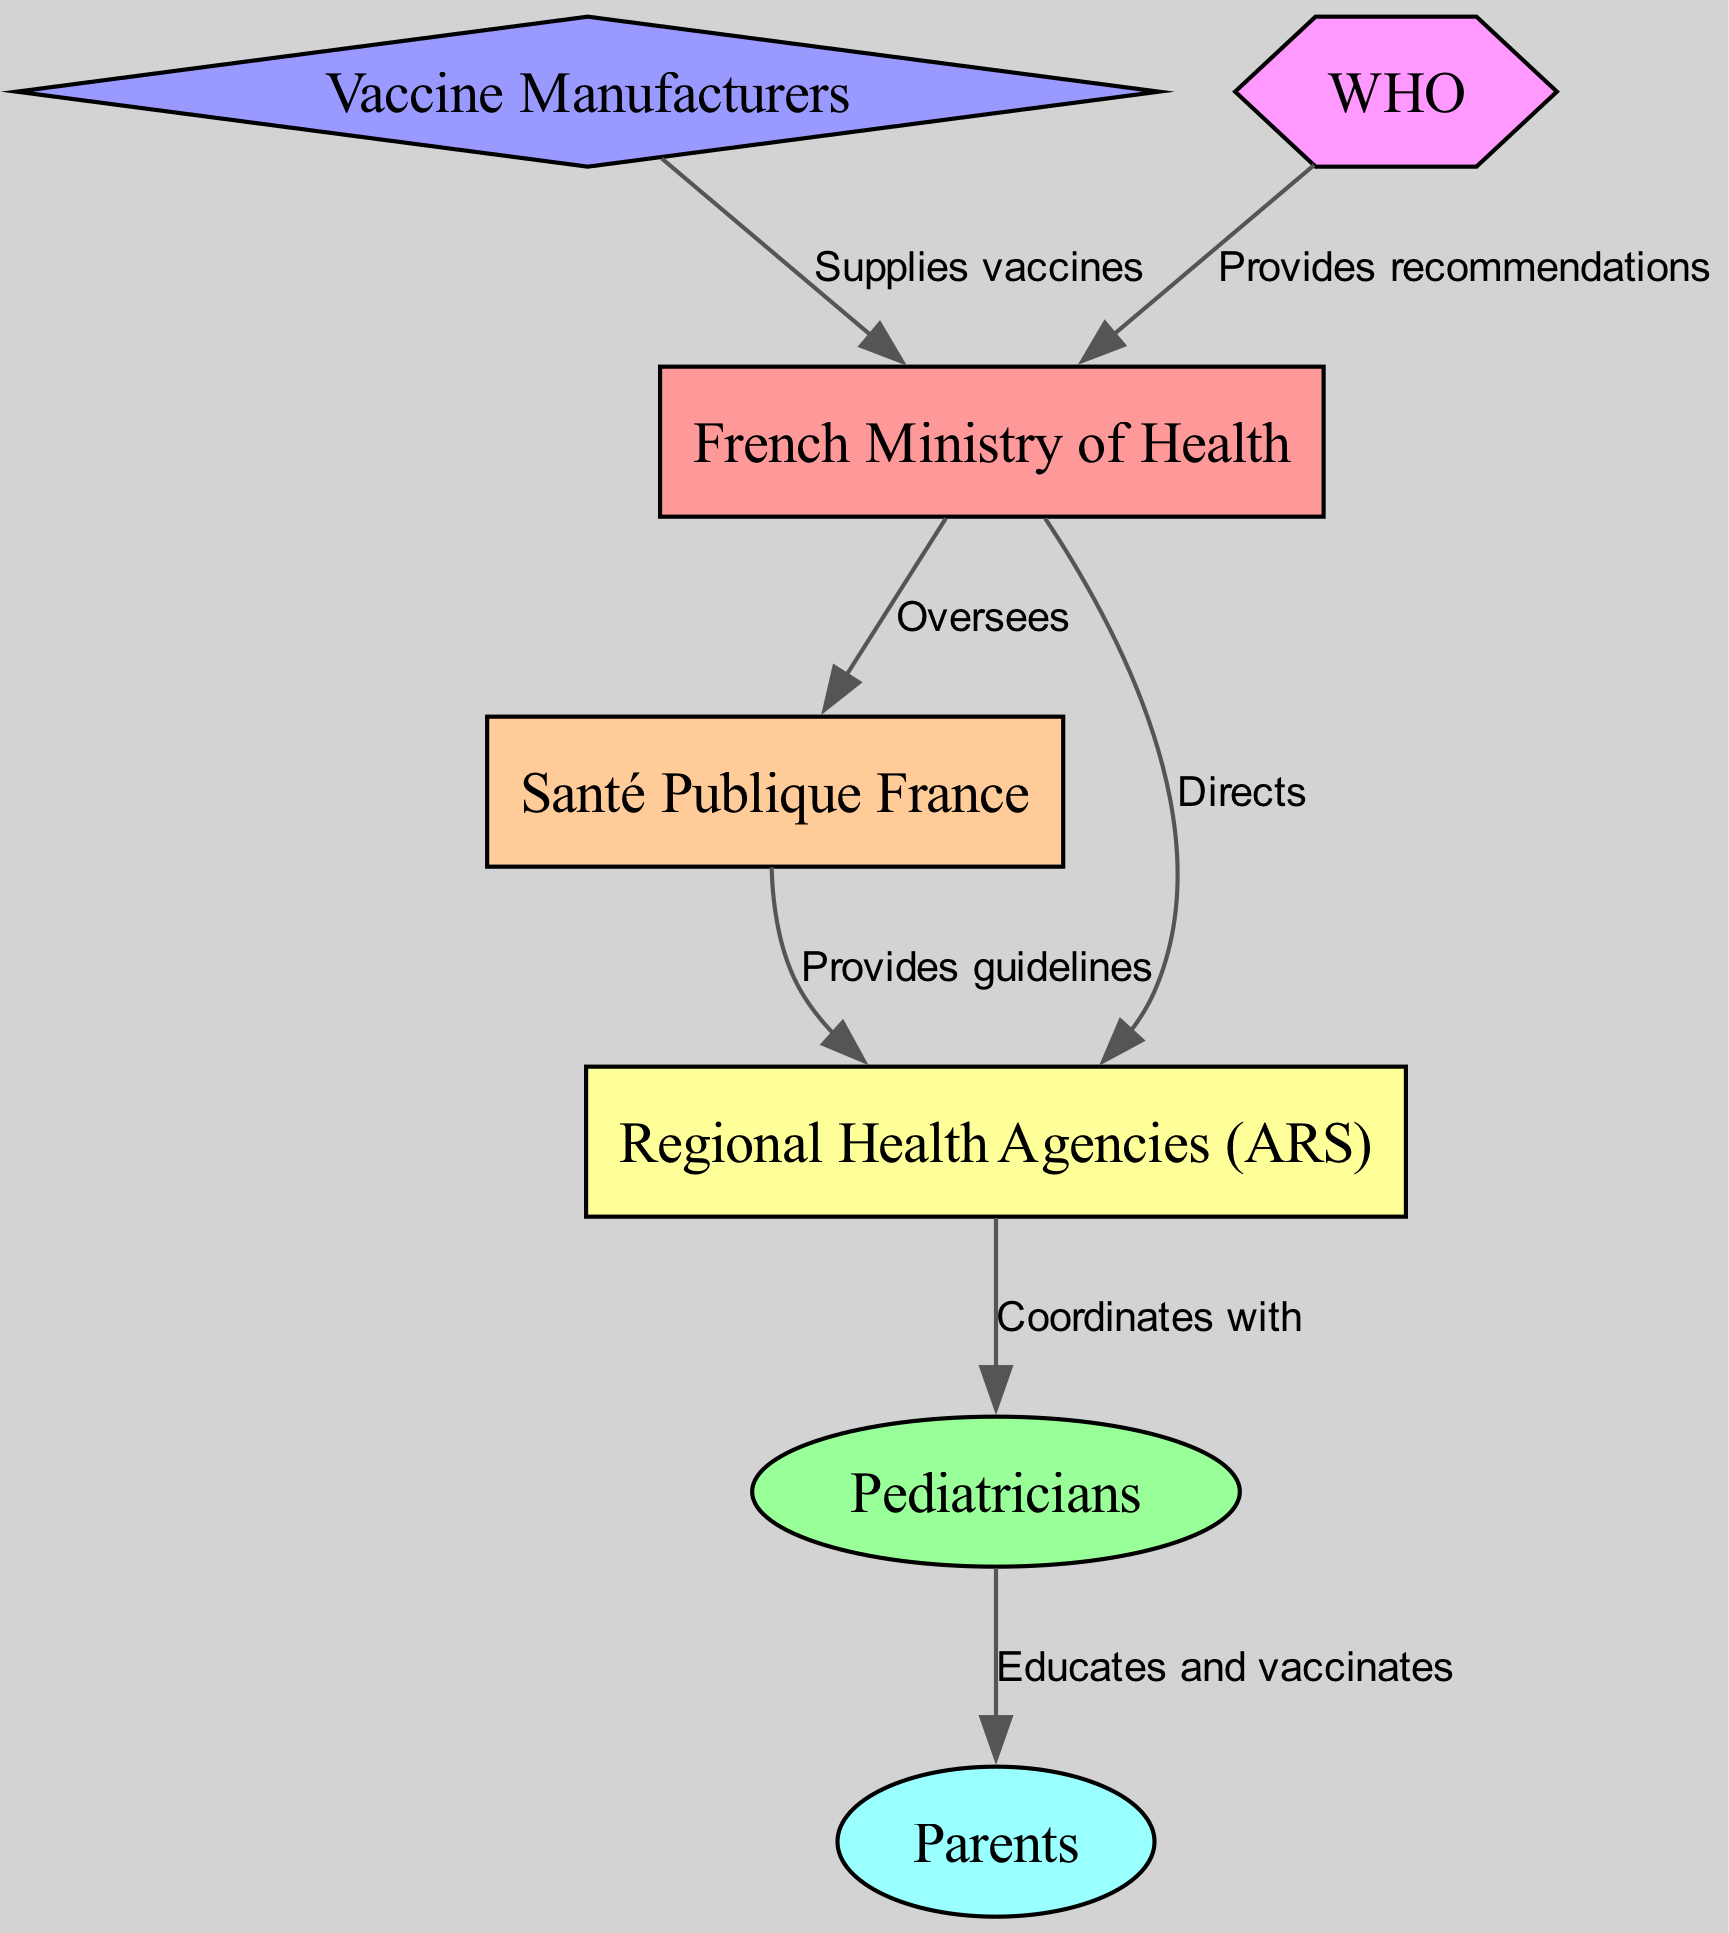What is the total number of nodes in the diagram? The diagram contains a variety of stakeholders involved in childhood vaccination programs in France. By counting each entity listed in the nodes section of the data, we find there are 7 distinct stakeholders.
Answer: 7 Which entity coordinates with pediatricians? The diagram indicates that the Regional Health Agencies (ARS) have a relationship defined as "Coordinates with" towards the Pediatricians, showing their collaborative role in vaccination efforts.
Answer: Regional Health Agencies (ARS) What is the relationship between the French Ministry of Health and Santé Publique France? The edge labeled "Oversees" connects the French Ministry of Health to Santé Publique France, indicating a supervisory role in their operations regarding public health.
Answer: Oversees How many edges connect the entities in the diagram? By reviewing the edges section of the data, we conclude that there are 6 distinct relationships defined between the various entities involved in childhood vaccination programs.
Answer: 6 Which entity supplies vaccines? The diagram clearly states that Vaccine Manufacturers have a relationship labeled "Supplies vaccines" directed towards the French Ministry of Health, indicating their role in providing the necessary vaccines for the program.
Answer: Vaccine Manufacturers What type of entity is the WHO in the diagram? In the visual representation, WHO is illustrated as a hexagon shape, which is distinctive and identifies it as a specific type of stakeholder with a role defined by the edge connected to the French Ministry of Health.
Answer: Hexagon What entity educates and vaccinates parents? The relationship displayed on the diagram indicates that Pediatricians are responsible for educating and vaccinating the Parents, highlighting their direct involvement in the vaccination process.
Answer: Pediatricians Which entity provides recommendations to the French Ministry of Health? According to the diagram, the WHO provides "Provides recommendations" to the French Ministry of Health, showcasing its advisory role in vaccination policies and practices.
Answer: WHO 